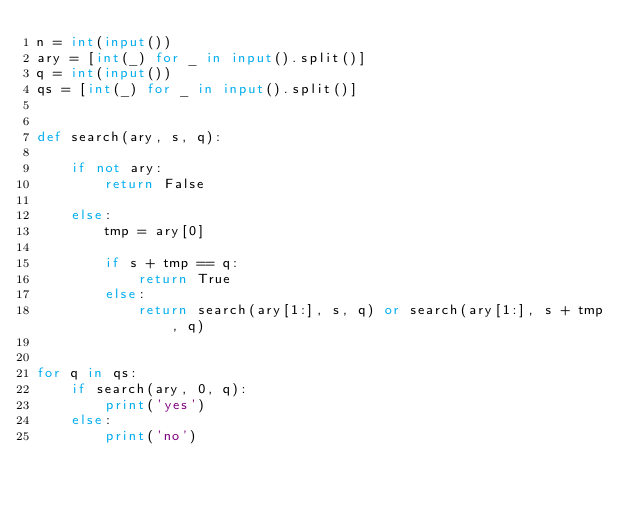<code> <loc_0><loc_0><loc_500><loc_500><_Python_>n = int(input())
ary = [int(_) for _ in input().split()]
q = int(input())
qs = [int(_) for _ in input().split()]


def search(ary, s, q):

    if not ary:
        return False

    else:
        tmp = ary[0]

        if s + tmp == q:
            return True
        else:
            return search(ary[1:], s, q) or search(ary[1:], s + tmp, q)


for q in qs:
    if search(ary, 0, q):
        print('yes')
    else:
        print('no')

</code> 